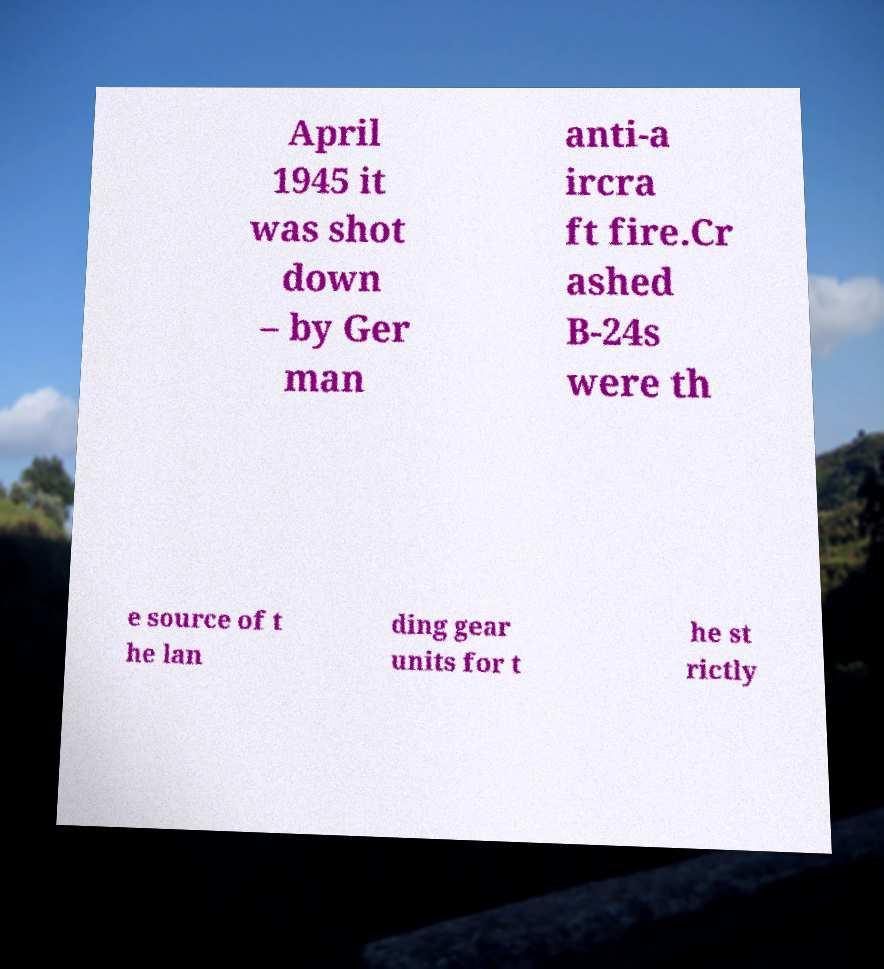For documentation purposes, I need the text within this image transcribed. Could you provide that? April 1945 it was shot down – by Ger man anti-a ircra ft fire.Cr ashed B-24s were th e source of t he lan ding gear units for t he st rictly 